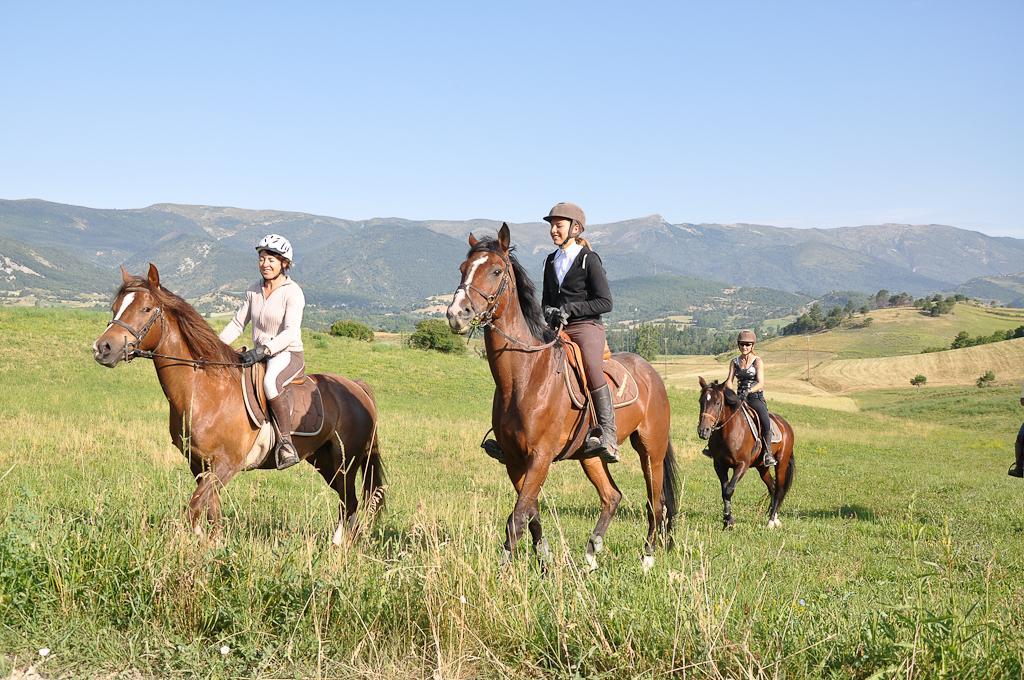Can you describe this image briefly? In this picture I can see few women riding horses and they wore caps on their heads and i can see grass and few trees and hills and a blue cloudy Sky. 